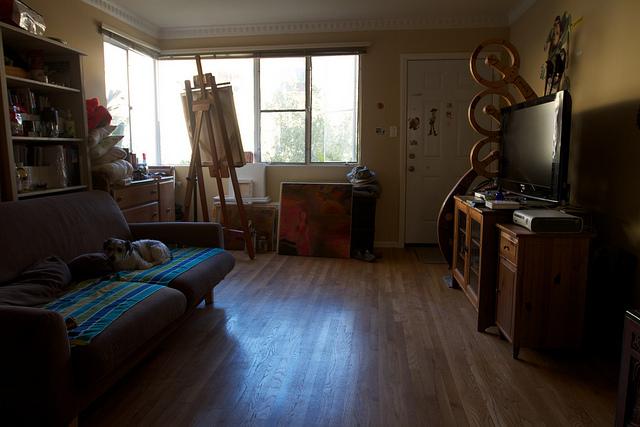How many windows?
Be succinct. 6. What kind of room is this?
Give a very brief answer. Living room. Does this room need more lighting?
Keep it brief. Yes. What is the floor made of?
Answer briefly. Wood. 